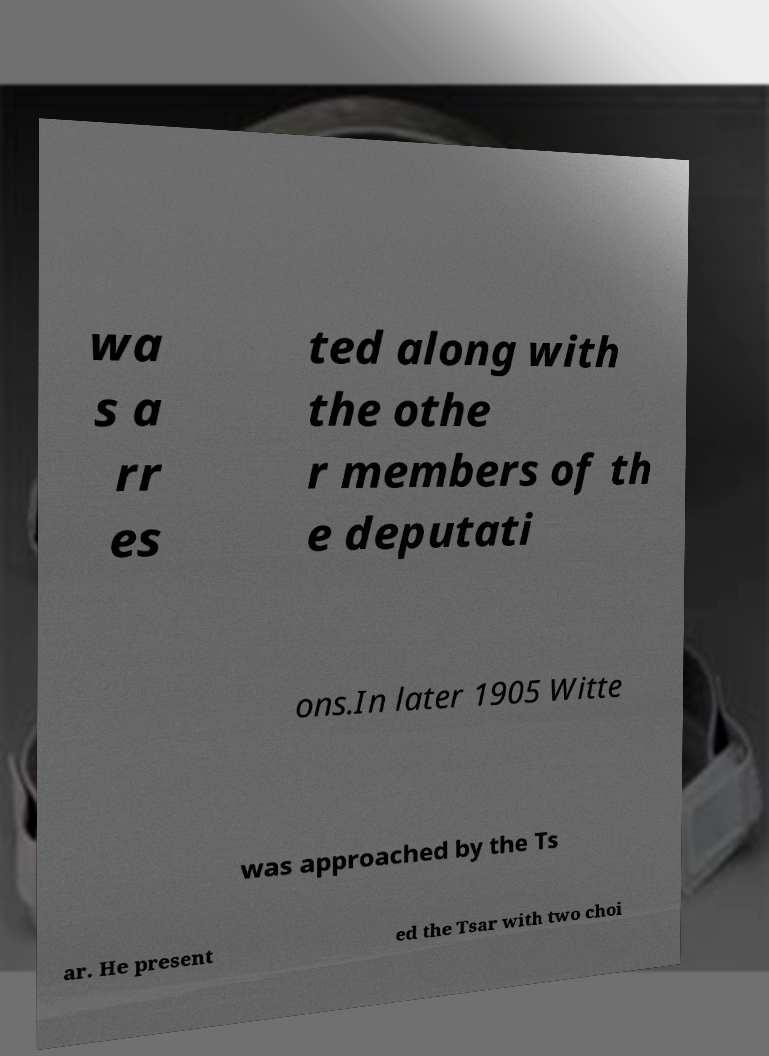I need the written content from this picture converted into text. Can you do that? wa s a rr es ted along with the othe r members of th e deputati ons.In later 1905 Witte was approached by the Ts ar. He present ed the Tsar with two choi 